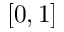<formula> <loc_0><loc_0><loc_500><loc_500>[ 0 , 1 ]</formula> 